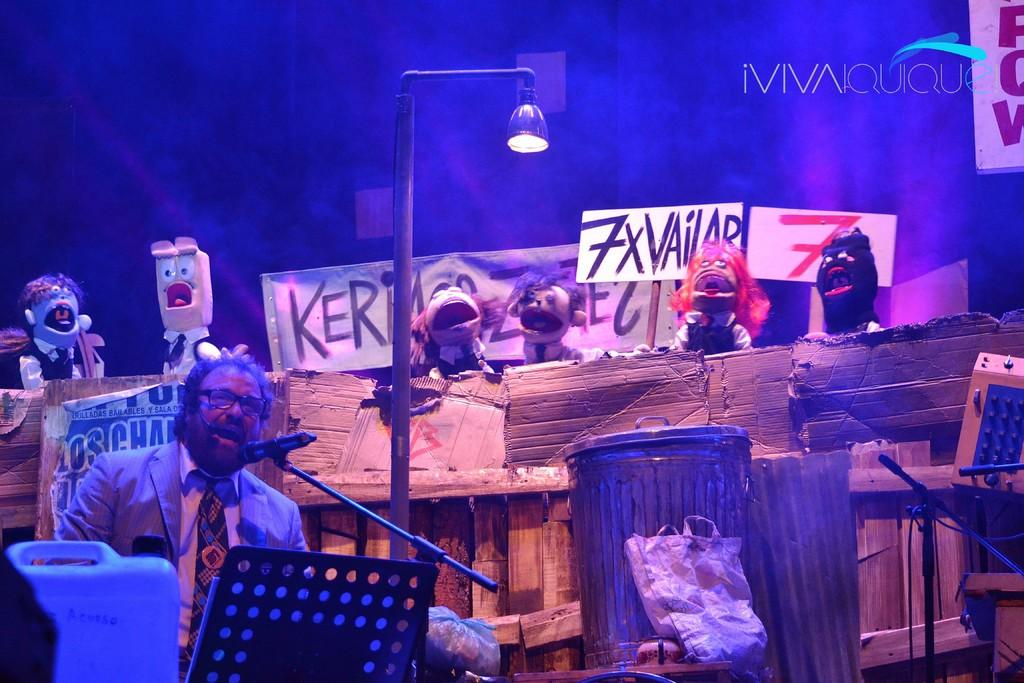What is the man in the image doing? The man is talking on a mic in the image. What type of clothing is the man wearing? The man is wearing a blazer and a tie in the image. What accessory is the man wearing on his face? The man is wearing spectacles in the image. What objects can be seen in the image besides the man? There is a can, a drum, toys, banners, a pole, a light, and a bag in the image. Can you tell me how many stores are visible in the image? There are no stores present in the image. What type of breath does the man have while talking on the mic? The image does not provide information about the man's breath while talking on the mic. 